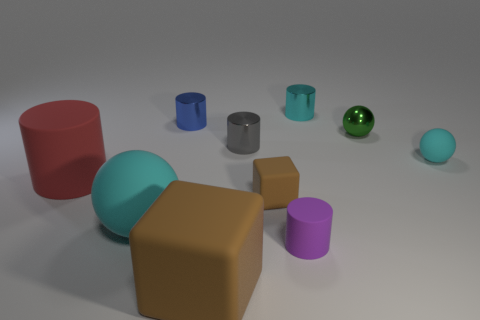Subtract all balls. How many objects are left? 7 Add 6 small rubber balls. How many small rubber balls are left? 7 Add 8 matte cubes. How many matte cubes exist? 10 Subtract 1 brown cubes. How many objects are left? 9 Subtract all tiny cyan things. Subtract all tiny cyan balls. How many objects are left? 7 